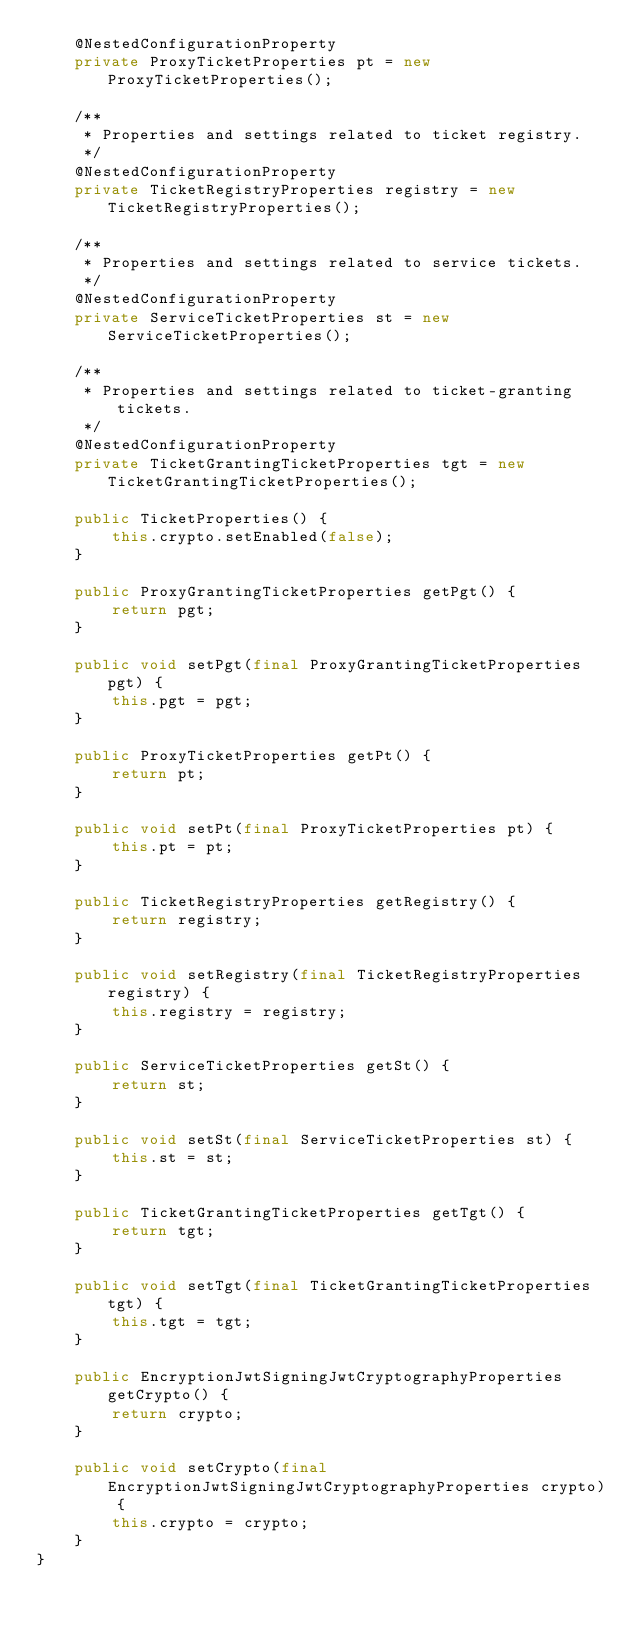<code> <loc_0><loc_0><loc_500><loc_500><_Java_>    @NestedConfigurationProperty
    private ProxyTicketProperties pt = new ProxyTicketProperties();

    /**
     * Properties and settings related to ticket registry.
     */
    @NestedConfigurationProperty
    private TicketRegistryProperties registry = new TicketRegistryProperties();

    /**
     * Properties and settings related to service tickets.
     */
    @NestedConfigurationProperty
    private ServiceTicketProperties st = new ServiceTicketProperties();

    /**
     * Properties and settings related to ticket-granting tickets.
     */
    @NestedConfigurationProperty
    private TicketGrantingTicketProperties tgt = new TicketGrantingTicketProperties();

    public TicketProperties() {
        this.crypto.setEnabled(false);
    }

    public ProxyGrantingTicketProperties getPgt() {
        return pgt;
    }

    public void setPgt(final ProxyGrantingTicketProperties pgt) {
        this.pgt = pgt;
    }

    public ProxyTicketProperties getPt() {
        return pt;
    }

    public void setPt(final ProxyTicketProperties pt) {
        this.pt = pt;
    }

    public TicketRegistryProperties getRegistry() {
        return registry;
    }

    public void setRegistry(final TicketRegistryProperties registry) {
        this.registry = registry;
    }

    public ServiceTicketProperties getSt() {
        return st;
    }

    public void setSt(final ServiceTicketProperties st) {
        this.st = st;
    }

    public TicketGrantingTicketProperties getTgt() {
        return tgt;
    }

    public void setTgt(final TicketGrantingTicketProperties tgt) {
        this.tgt = tgt;
    }

    public EncryptionJwtSigningJwtCryptographyProperties getCrypto() {
        return crypto;
    }

    public void setCrypto(final EncryptionJwtSigningJwtCryptographyProperties crypto) {
        this.crypto = crypto;
    }
}
</code> 